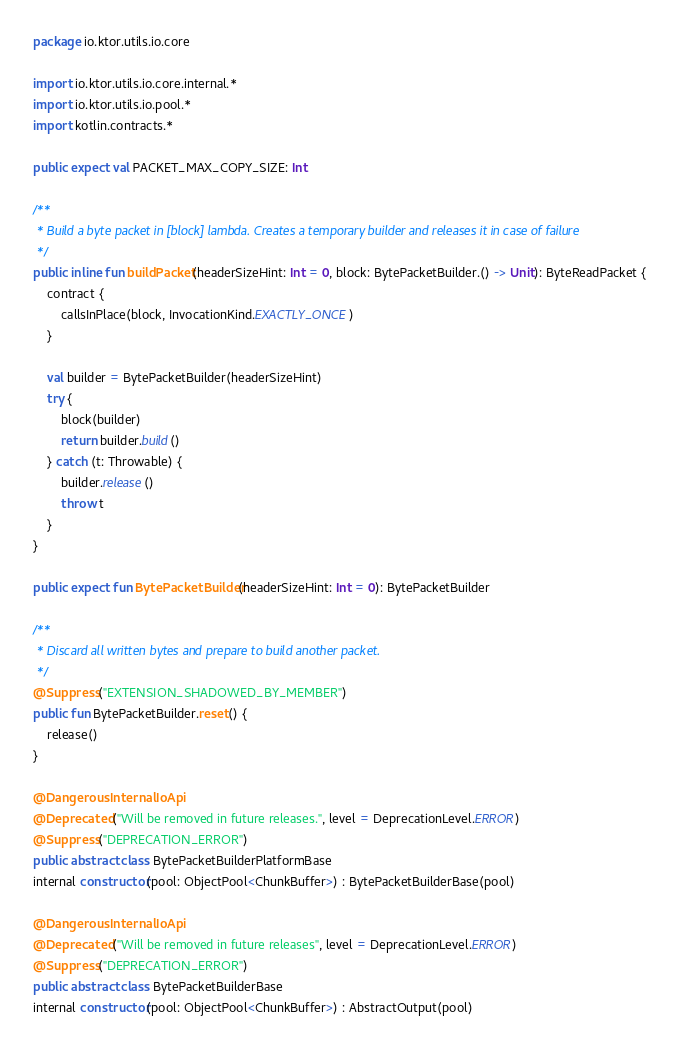<code> <loc_0><loc_0><loc_500><loc_500><_Kotlin_>package io.ktor.utils.io.core

import io.ktor.utils.io.core.internal.*
import io.ktor.utils.io.pool.*
import kotlin.contracts.*

public expect val PACKET_MAX_COPY_SIZE: Int

/**
 * Build a byte packet in [block] lambda. Creates a temporary builder and releases it in case of failure
 */
public inline fun buildPacket(headerSizeHint: Int = 0, block: BytePacketBuilder.() -> Unit): ByteReadPacket {
    contract {
        callsInPlace(block, InvocationKind.EXACTLY_ONCE)
    }

    val builder = BytePacketBuilder(headerSizeHint)
    try {
        block(builder)
        return builder.build()
    } catch (t: Throwable) {
        builder.release()
        throw t
    }
}

public expect fun BytePacketBuilder(headerSizeHint: Int = 0): BytePacketBuilder

/**
 * Discard all written bytes and prepare to build another packet.
 */
@Suppress("EXTENSION_SHADOWED_BY_MEMBER")
public fun BytePacketBuilder.reset() {
    release()
}

@DangerousInternalIoApi
@Deprecated("Will be removed in future releases.", level = DeprecationLevel.ERROR)
@Suppress("DEPRECATION_ERROR")
public abstract class BytePacketBuilderPlatformBase
internal constructor(pool: ObjectPool<ChunkBuffer>) : BytePacketBuilderBase(pool)

@DangerousInternalIoApi
@Deprecated("Will be removed in future releases", level = DeprecationLevel.ERROR)
@Suppress("DEPRECATION_ERROR")
public abstract class BytePacketBuilderBase
internal constructor(pool: ObjectPool<ChunkBuffer>) : AbstractOutput(pool)
</code> 